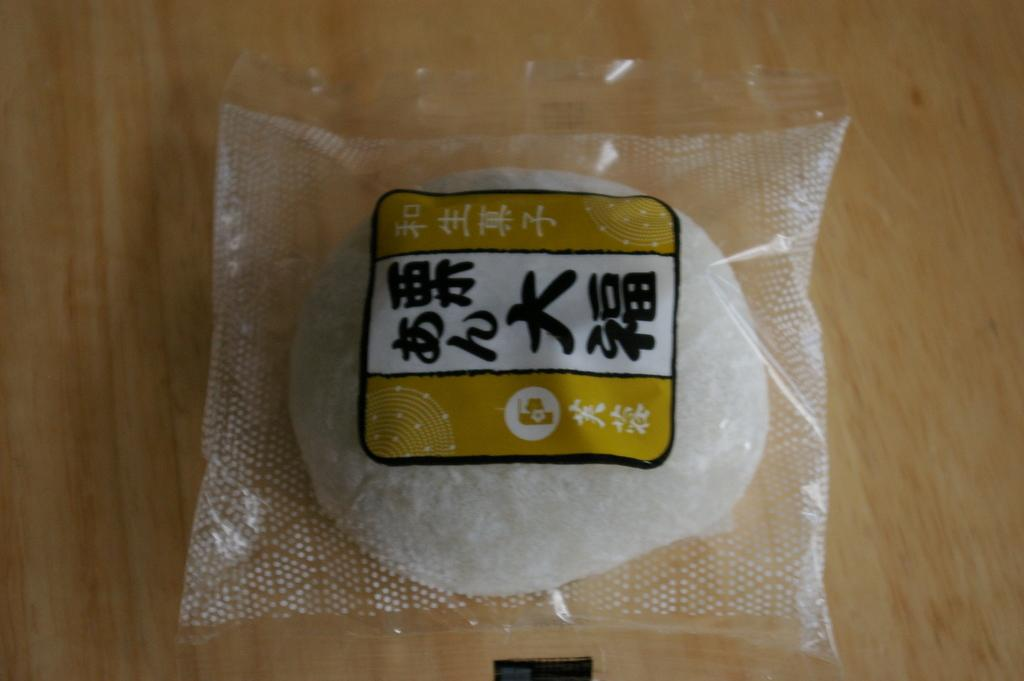What is contained within the cover that is visible in the image? There is food packed in a cover in the image. How can the contents of the cover be identified? There is a label on the plastic cover. What type of surface is the food placed on? The food is placed on a wooden surface. How many apples are visible in the image? There are no apples present in the image. What type of grape is being used to decorate the wooden surface? There is no grape present in the image, and therefore no decoration with grapes can be observed. 